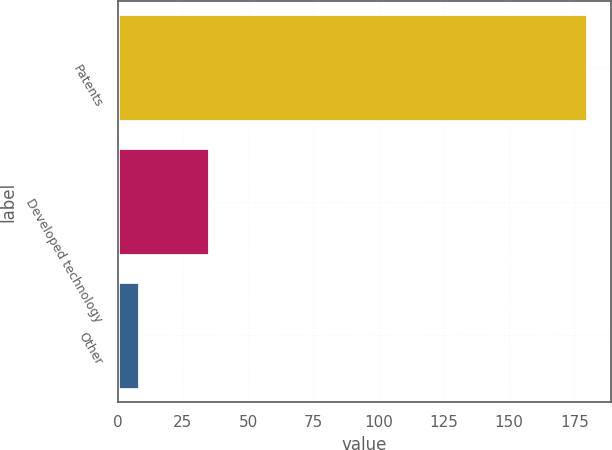Convert chart. <chart><loc_0><loc_0><loc_500><loc_500><bar_chart><fcel>Patents<fcel>Developed technology<fcel>Other<nl><fcel>179.9<fcel>35.1<fcel>8.1<nl></chart> 